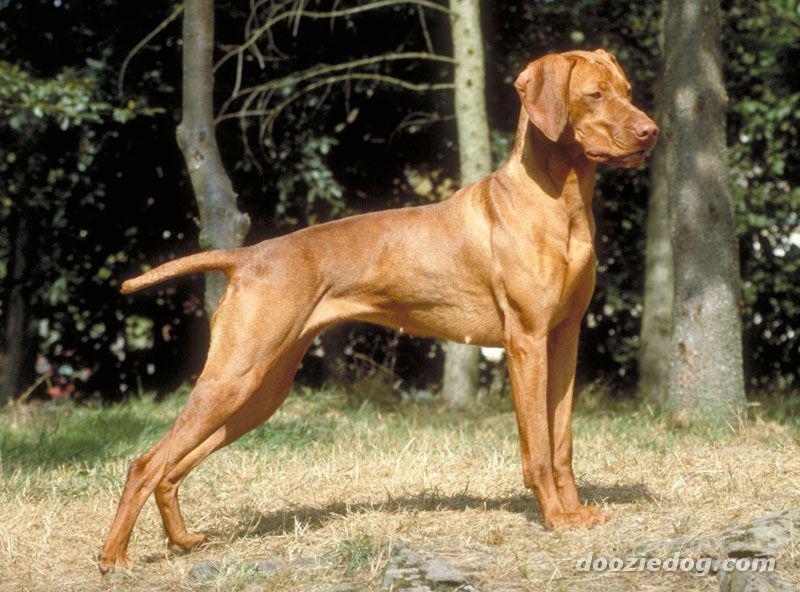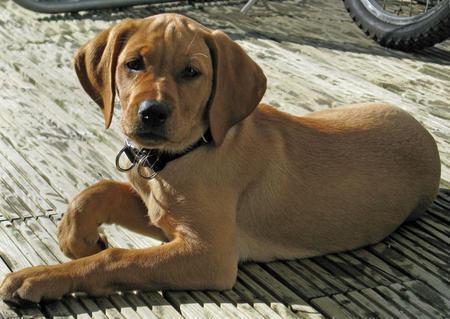The first image is the image on the left, the second image is the image on the right. Analyze the images presented: Is the assertion "The combined images include one reddish-brown reclining dog and at least two spaniels with mostly white bodies and darker face markings." valid? Answer yes or no. No. The first image is the image on the left, the second image is the image on the right. Considering the images on both sides, is "The right image contains exactly one dog." valid? Answer yes or no. Yes. 